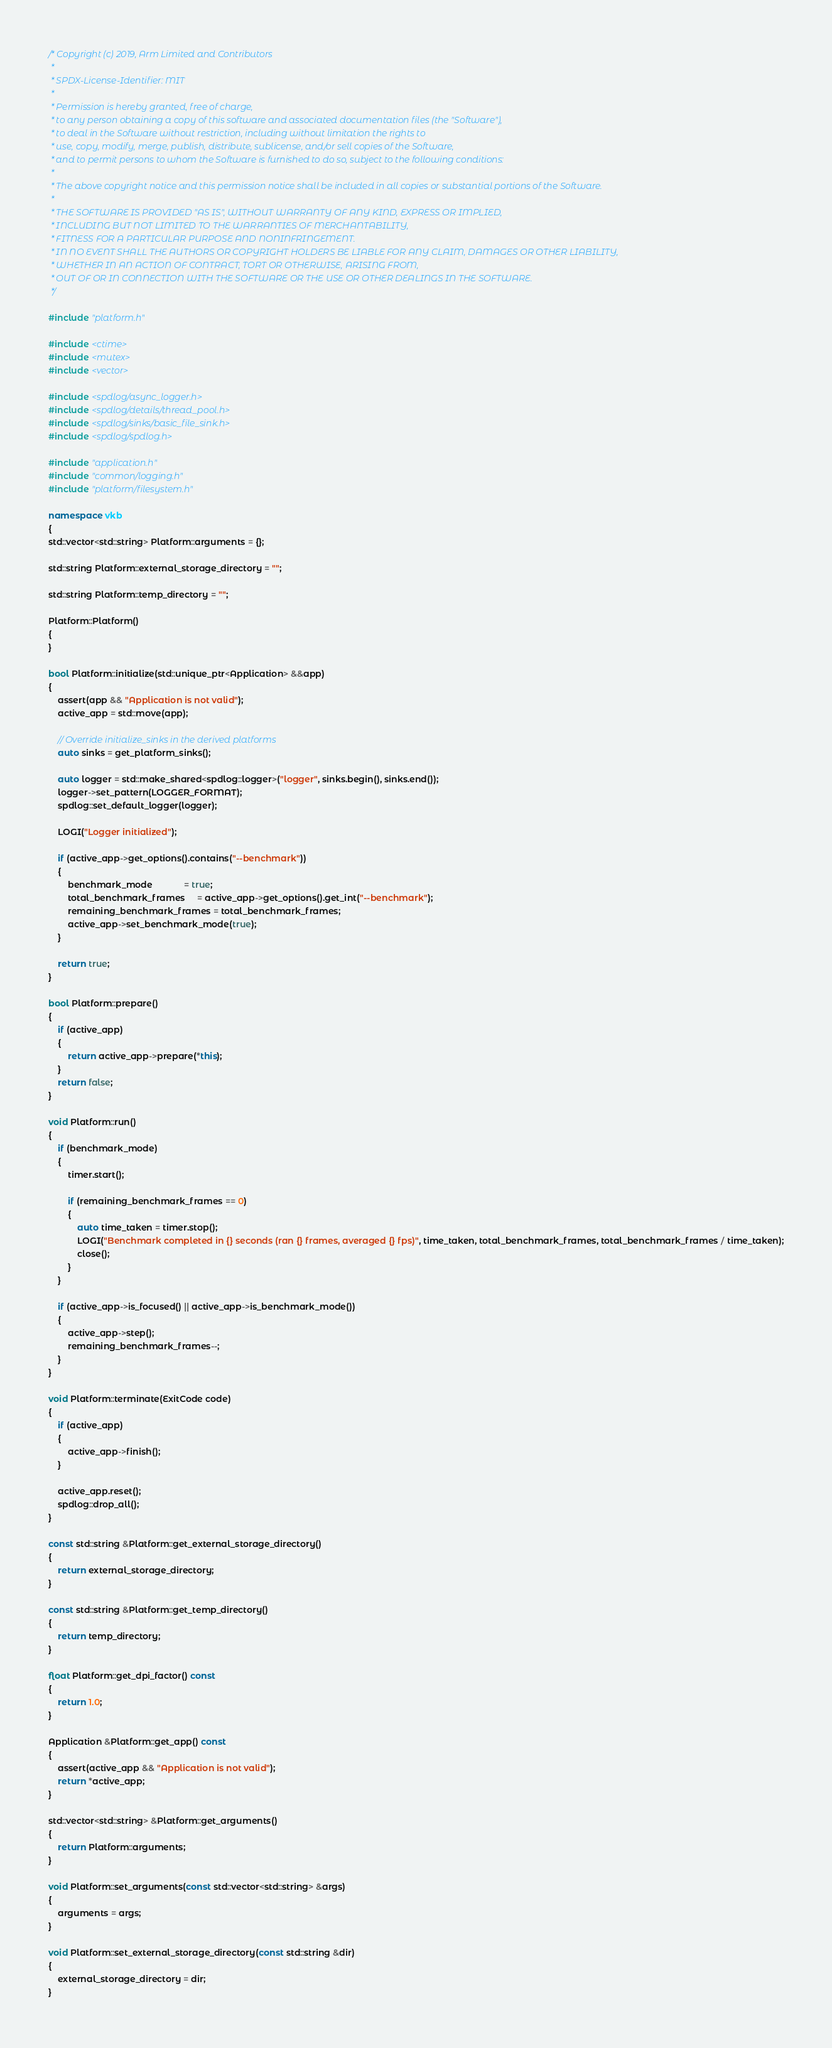<code> <loc_0><loc_0><loc_500><loc_500><_C++_>/* Copyright (c) 2019, Arm Limited and Contributors
 *
 * SPDX-License-Identifier: MIT
 *
 * Permission is hereby granted, free of charge,
 * to any person obtaining a copy of this software and associated documentation files (the "Software"),
 * to deal in the Software without restriction, including without limitation the rights to
 * use, copy, modify, merge, publish, distribute, sublicense, and/or sell copies of the Software,
 * and to permit persons to whom the Software is furnished to do so, subject to the following conditions:
 *
 * The above copyright notice and this permission notice shall be included in all copies or substantial portions of the Software.
 *
 * THE SOFTWARE IS PROVIDED "AS IS", WITHOUT WARRANTY OF ANY KIND, EXPRESS OR IMPLIED,
 * INCLUDING BUT NOT LIMITED TO THE WARRANTIES OF MERCHANTABILITY,
 * FITNESS FOR A PARTICULAR PURPOSE AND NONINFRINGEMENT.
 * IN NO EVENT SHALL THE AUTHORS OR COPYRIGHT HOLDERS BE LIABLE FOR ANY CLAIM, DAMAGES OR OTHER LIABILITY,
 * WHETHER IN AN ACTION OF CONTRACT, TORT OR OTHERWISE, ARISING FROM,
 * OUT OF OR IN CONNECTION WITH THE SOFTWARE OR THE USE OR OTHER DEALINGS IN THE SOFTWARE.
 */

#include "platform.h"

#include <ctime>
#include <mutex>
#include <vector>

#include <spdlog/async_logger.h>
#include <spdlog/details/thread_pool.h>
#include <spdlog/sinks/basic_file_sink.h>
#include <spdlog/spdlog.h>

#include "application.h"
#include "common/logging.h"
#include "platform/filesystem.h"

namespace vkb
{
std::vector<std::string> Platform::arguments = {};

std::string Platform::external_storage_directory = "";

std::string Platform::temp_directory = "";

Platform::Platform()
{
}

bool Platform::initialize(std::unique_ptr<Application> &&app)
{
	assert(app && "Application is not valid");
	active_app = std::move(app);

	// Override initialize_sinks in the derived platforms
	auto sinks = get_platform_sinks();

	auto logger = std::make_shared<spdlog::logger>("logger", sinks.begin(), sinks.end());
	logger->set_pattern(LOGGER_FORMAT);
	spdlog::set_default_logger(logger);

	LOGI("Logger initialized");

	if (active_app->get_options().contains("--benchmark"))
	{
		benchmark_mode             = true;
		total_benchmark_frames     = active_app->get_options().get_int("--benchmark");
		remaining_benchmark_frames = total_benchmark_frames;
		active_app->set_benchmark_mode(true);
	}

	return true;
}

bool Platform::prepare()
{
	if (active_app)
	{
		return active_app->prepare(*this);
	}
	return false;
}

void Platform::run()
{
	if (benchmark_mode)
	{
		timer.start();

		if (remaining_benchmark_frames == 0)
		{
			auto time_taken = timer.stop();
			LOGI("Benchmark completed in {} seconds (ran {} frames, averaged {} fps)", time_taken, total_benchmark_frames, total_benchmark_frames / time_taken);
			close();
		}
	}

	if (active_app->is_focused() || active_app->is_benchmark_mode())
	{
		active_app->step();
		remaining_benchmark_frames--;
	}
}

void Platform::terminate(ExitCode code)
{
	if (active_app)
	{
		active_app->finish();
	}

	active_app.reset();
	spdlog::drop_all();
}

const std::string &Platform::get_external_storage_directory()
{
	return external_storage_directory;
}

const std::string &Platform::get_temp_directory()
{
	return temp_directory;
}

float Platform::get_dpi_factor() const
{
	return 1.0;
}

Application &Platform::get_app() const
{
	assert(active_app && "Application is not valid");
	return *active_app;
}

std::vector<std::string> &Platform::get_arguments()
{
	return Platform::arguments;
}

void Platform::set_arguments(const std::vector<std::string> &args)
{
	arguments = args;
}

void Platform::set_external_storage_directory(const std::string &dir)
{
	external_storage_directory = dir;
}
</code> 